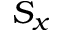Convert formula to latex. <formula><loc_0><loc_0><loc_500><loc_500>S _ { x }</formula> 